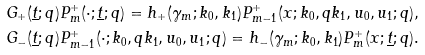<formula> <loc_0><loc_0><loc_500><loc_500>& G _ { + } ( \underline { t } ; q ) P _ { m } ^ { + } ( \cdot ; \underline { t } ; q ) = h _ { + } ( \gamma _ { m } ; k _ { 0 } , k _ { 1 } ) P _ { m - 1 } ^ { + } ( x ; k _ { 0 } , q k _ { 1 } , u _ { 0 } , u _ { 1 } ; q ) , \\ & G _ { - } ( \underline { t } ; q ) P _ { m - 1 } ^ { + } ( \cdot ; k _ { 0 } , q k _ { 1 } , u _ { 0 } , u _ { 1 } ; q ) = h _ { - } ( \gamma _ { m } ; k _ { 0 } , k _ { 1 } ) P _ { m } ^ { + } ( x ; \underline { t } ; q ) .</formula> 